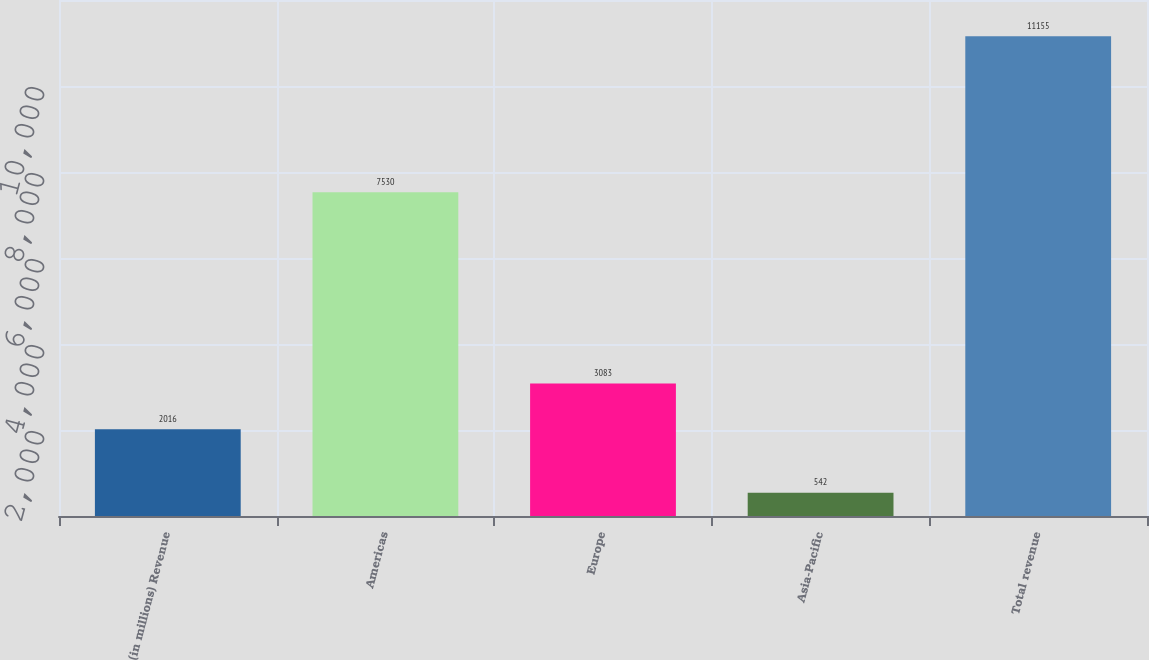Convert chart to OTSL. <chart><loc_0><loc_0><loc_500><loc_500><bar_chart><fcel>(in millions) Revenue<fcel>Americas<fcel>Europe<fcel>Asia-Pacific<fcel>Total revenue<nl><fcel>2016<fcel>7530<fcel>3083<fcel>542<fcel>11155<nl></chart> 